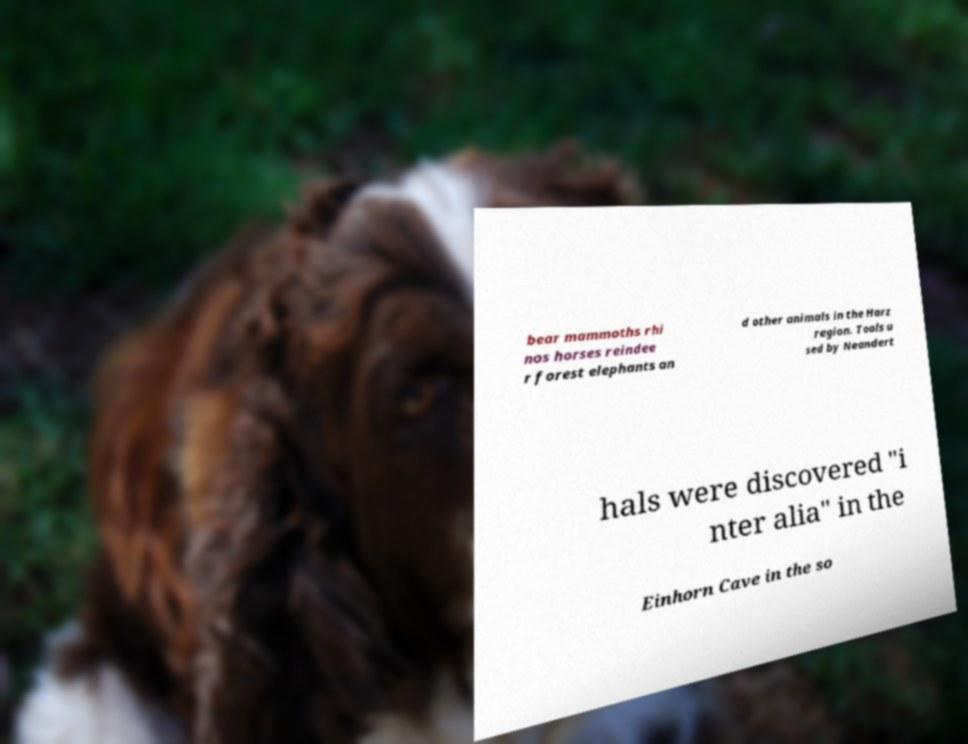Please identify and transcribe the text found in this image. bear mammoths rhi nos horses reindee r forest elephants an d other animals in the Harz region. Tools u sed by Neandert hals were discovered "i nter alia" in the Einhorn Cave in the so 